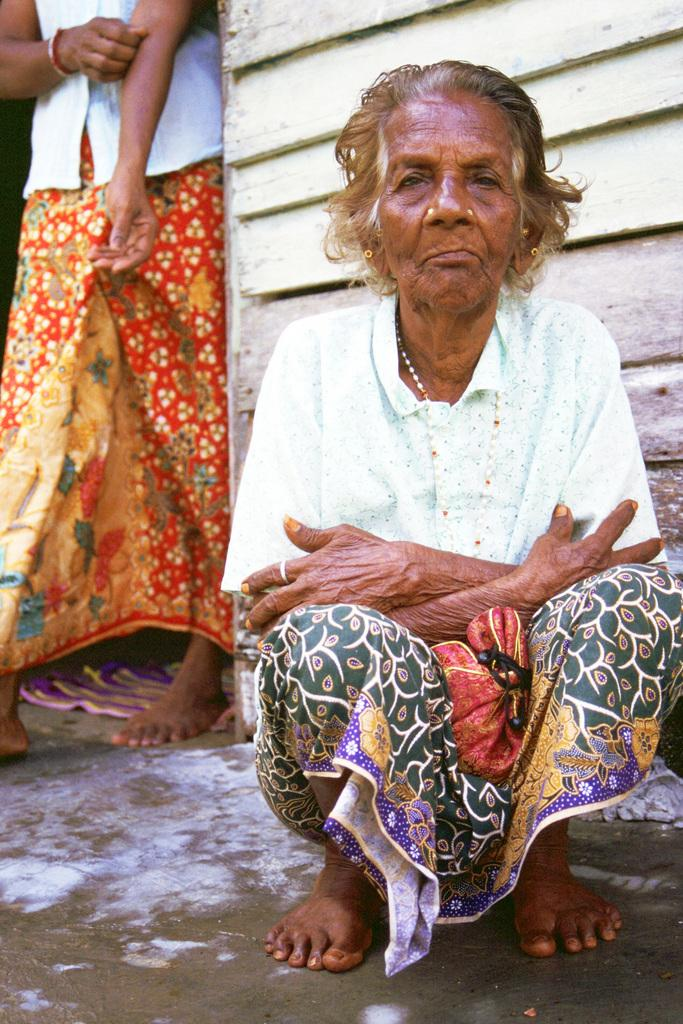How many women are present in the image? There are two women in the image. What are the positions of the women in the image? One of the women is sitting on the floor, while the other woman is standing on the floor. What type of circle can be seen in the image? There is no circle present in the image. 